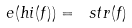Convert formula to latex. <formula><loc_0><loc_0><loc_500><loc_500>\ e ( h i ( f ) ) = \ s t r ( f )</formula> 